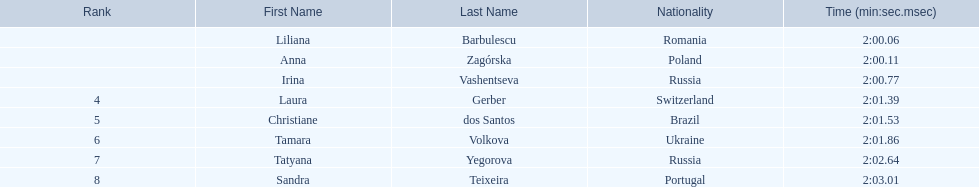Who were all of the athletes? Liliana Barbulescu, Anna Zagórska, Irina Vashentseva, Laura Gerber, Christiane dos Santos, Tamara Volkova, Tatyana Yegorova, Sandra Teixeira. What were their finishing times? 2:00.06, 2:00.11, 2:00.77, 2:01.39, 2:01.53, 2:01.86, 2:02.64, 2:03.01. Which athlete finished earliest? Liliana Barbulescu. 